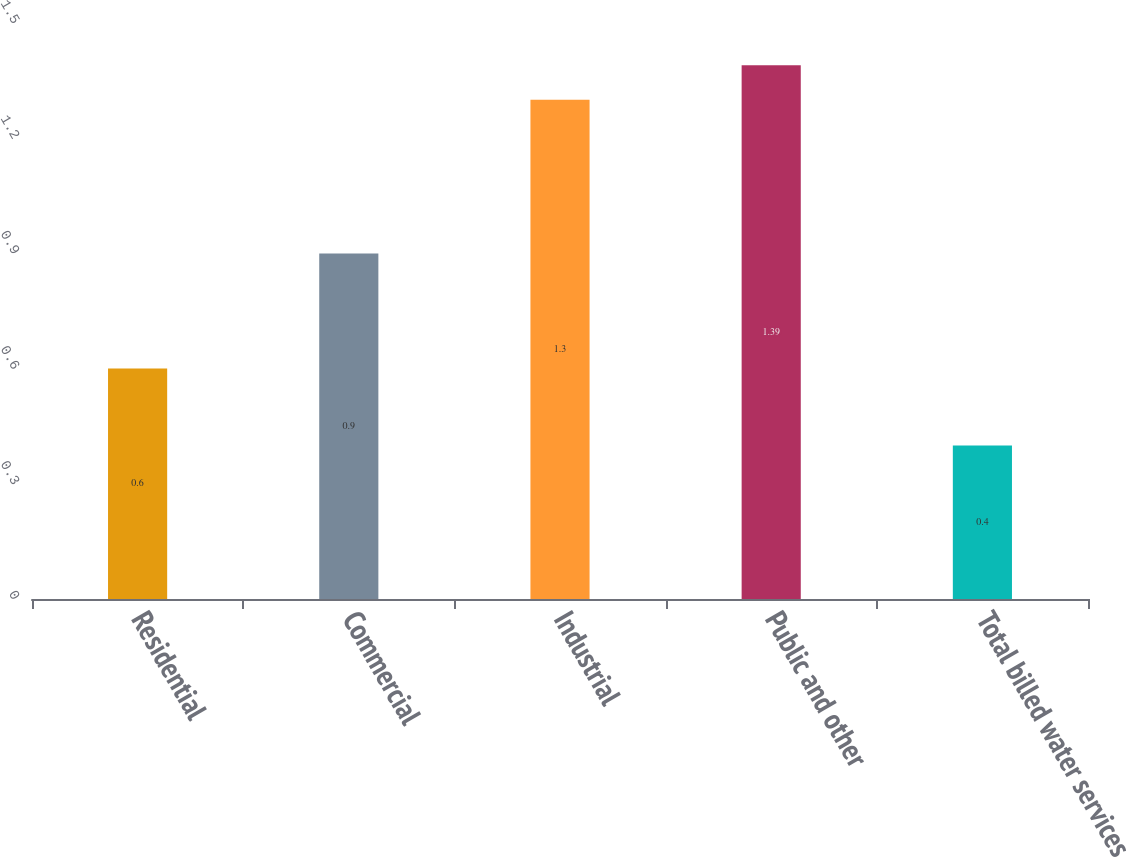Convert chart to OTSL. <chart><loc_0><loc_0><loc_500><loc_500><bar_chart><fcel>Residential<fcel>Commercial<fcel>Industrial<fcel>Public and other<fcel>Total billed water services<nl><fcel>0.6<fcel>0.9<fcel>1.3<fcel>1.39<fcel>0.4<nl></chart> 